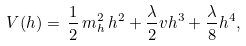<formula> <loc_0><loc_0><loc_500><loc_500>V ( h ) = \, \frac { 1 } { 2 } \, m ^ { 2 } _ { h } \, h ^ { 2 } + \frac { \lambda } { 2 } v h ^ { 3 } + \frac { \lambda } { 8 } h ^ { 4 } ,</formula> 